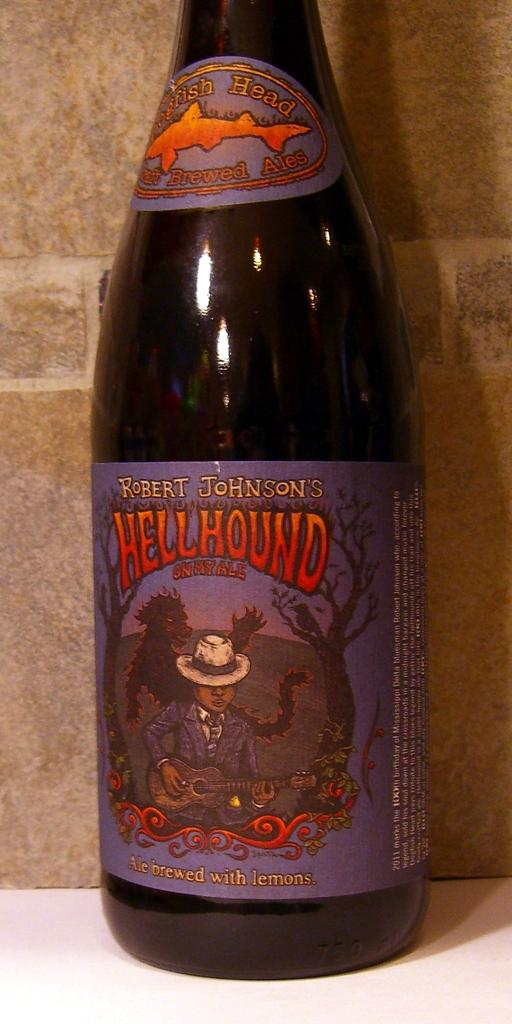<image>
Offer a succinct explanation of the picture presented. A bottle of beat that says Dogfish Head at the top of the bottle. 